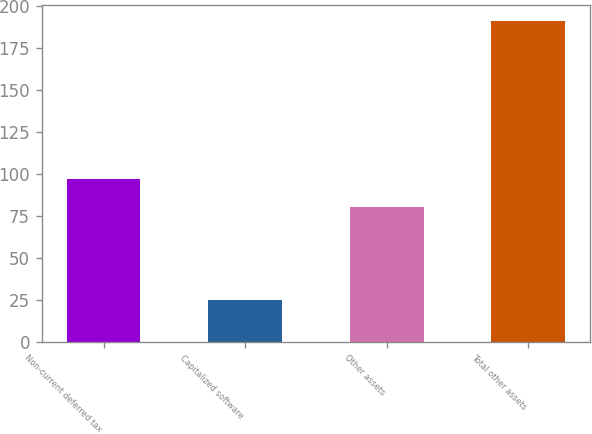Convert chart to OTSL. <chart><loc_0><loc_0><loc_500><loc_500><bar_chart><fcel>Non-current deferred tax<fcel>Capitalized software<fcel>Other assets<fcel>Total other assets<nl><fcel>96.6<fcel>25<fcel>80<fcel>191<nl></chart> 